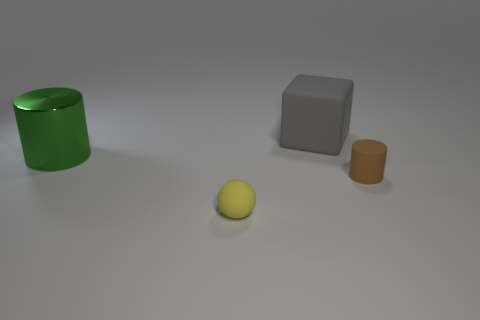What shape is the tiny brown object that is the same material as the big cube?
Offer a very short reply. Cylinder. There is a large thing left of the large gray thing; is it the same shape as the small brown rubber object?
Keep it short and to the point. Yes. How many objects are either large cylinders or large cyan rubber cylinders?
Ensure brevity in your answer.  1. What is the thing that is right of the small yellow rubber object and in front of the gray thing made of?
Offer a terse response. Rubber. Is the brown cylinder the same size as the green cylinder?
Make the answer very short. No. There is a matte object behind the cylinder that is to the right of the big gray cube; what size is it?
Your response must be concise. Large. How many things are both behind the brown matte cylinder and on the right side of the large metallic cylinder?
Provide a succinct answer. 1. There is a object that is in front of the cylinder in front of the large green metallic object; is there a tiny brown cylinder behind it?
Provide a short and direct response. Yes. What shape is the gray rubber thing that is the same size as the metallic thing?
Make the answer very short. Cube. Does the large gray matte thing have the same shape as the brown matte object?
Make the answer very short. No. 